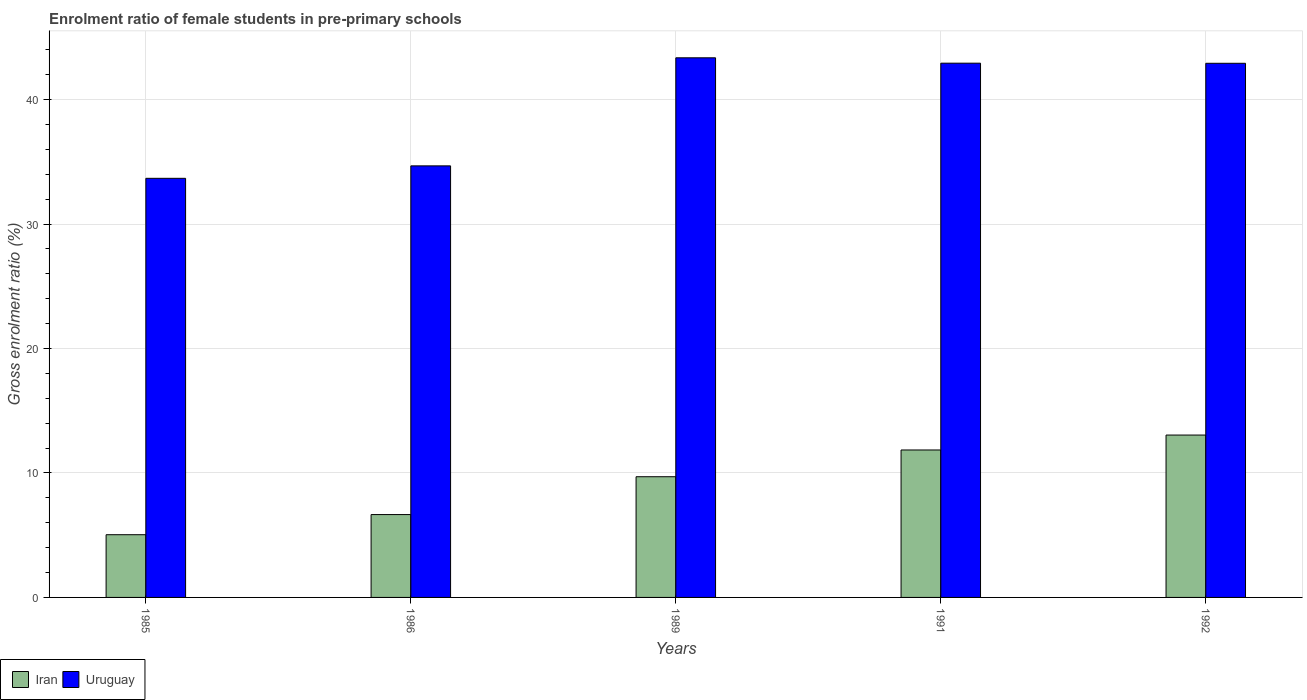Are the number of bars on each tick of the X-axis equal?
Ensure brevity in your answer.  Yes. What is the enrolment ratio of female students in pre-primary schools in Iran in 1992?
Offer a very short reply. 13.05. Across all years, what is the maximum enrolment ratio of female students in pre-primary schools in Uruguay?
Ensure brevity in your answer.  43.36. Across all years, what is the minimum enrolment ratio of female students in pre-primary schools in Uruguay?
Provide a short and direct response. 33.67. In which year was the enrolment ratio of female students in pre-primary schools in Uruguay maximum?
Your answer should be compact. 1989. In which year was the enrolment ratio of female students in pre-primary schools in Uruguay minimum?
Provide a succinct answer. 1985. What is the total enrolment ratio of female students in pre-primary schools in Uruguay in the graph?
Your answer should be compact. 197.55. What is the difference between the enrolment ratio of female students in pre-primary schools in Uruguay in 1985 and that in 1991?
Your answer should be compact. -9.25. What is the difference between the enrolment ratio of female students in pre-primary schools in Iran in 1992 and the enrolment ratio of female students in pre-primary schools in Uruguay in 1986?
Provide a succinct answer. -21.63. What is the average enrolment ratio of female students in pre-primary schools in Iran per year?
Your response must be concise. 9.26. In the year 1985, what is the difference between the enrolment ratio of female students in pre-primary schools in Uruguay and enrolment ratio of female students in pre-primary schools in Iran?
Keep it short and to the point. 28.64. What is the ratio of the enrolment ratio of female students in pre-primary schools in Iran in 1985 to that in 1989?
Keep it short and to the point. 0.52. Is the enrolment ratio of female students in pre-primary schools in Iran in 1985 less than that in 1989?
Your answer should be compact. Yes. What is the difference between the highest and the second highest enrolment ratio of female students in pre-primary schools in Uruguay?
Your answer should be very brief. 0.43. What is the difference between the highest and the lowest enrolment ratio of female students in pre-primary schools in Iran?
Make the answer very short. 8.01. In how many years, is the enrolment ratio of female students in pre-primary schools in Iran greater than the average enrolment ratio of female students in pre-primary schools in Iran taken over all years?
Provide a short and direct response. 3. Is the sum of the enrolment ratio of female students in pre-primary schools in Iran in 1985 and 1989 greater than the maximum enrolment ratio of female students in pre-primary schools in Uruguay across all years?
Give a very brief answer. No. What does the 1st bar from the left in 1989 represents?
Give a very brief answer. Iran. What does the 1st bar from the right in 1992 represents?
Offer a very short reply. Uruguay. How many bars are there?
Provide a succinct answer. 10. How many years are there in the graph?
Your answer should be very brief. 5. What is the difference between two consecutive major ticks on the Y-axis?
Provide a short and direct response. 10. Does the graph contain any zero values?
Offer a very short reply. No. Does the graph contain grids?
Your answer should be compact. Yes. Where does the legend appear in the graph?
Provide a succinct answer. Bottom left. How many legend labels are there?
Offer a very short reply. 2. How are the legend labels stacked?
Give a very brief answer. Horizontal. What is the title of the graph?
Your response must be concise. Enrolment ratio of female students in pre-primary schools. Does "Least developed countries" appear as one of the legend labels in the graph?
Provide a short and direct response. No. What is the label or title of the Y-axis?
Your answer should be compact. Gross enrolment ratio (%). What is the Gross enrolment ratio (%) in Iran in 1985?
Offer a terse response. 5.04. What is the Gross enrolment ratio (%) of Uruguay in 1985?
Give a very brief answer. 33.67. What is the Gross enrolment ratio (%) of Iran in 1986?
Offer a terse response. 6.66. What is the Gross enrolment ratio (%) of Uruguay in 1986?
Provide a succinct answer. 34.67. What is the Gross enrolment ratio (%) of Iran in 1989?
Your answer should be very brief. 9.7. What is the Gross enrolment ratio (%) of Uruguay in 1989?
Keep it short and to the point. 43.36. What is the Gross enrolment ratio (%) of Iran in 1991?
Offer a terse response. 11.85. What is the Gross enrolment ratio (%) of Uruguay in 1991?
Provide a succinct answer. 42.93. What is the Gross enrolment ratio (%) in Iran in 1992?
Ensure brevity in your answer.  13.05. What is the Gross enrolment ratio (%) in Uruguay in 1992?
Ensure brevity in your answer.  42.92. Across all years, what is the maximum Gross enrolment ratio (%) in Iran?
Keep it short and to the point. 13.05. Across all years, what is the maximum Gross enrolment ratio (%) in Uruguay?
Your response must be concise. 43.36. Across all years, what is the minimum Gross enrolment ratio (%) in Iran?
Keep it short and to the point. 5.04. Across all years, what is the minimum Gross enrolment ratio (%) of Uruguay?
Ensure brevity in your answer.  33.67. What is the total Gross enrolment ratio (%) in Iran in the graph?
Your answer should be compact. 46.29. What is the total Gross enrolment ratio (%) in Uruguay in the graph?
Offer a terse response. 197.55. What is the difference between the Gross enrolment ratio (%) of Iran in 1985 and that in 1986?
Make the answer very short. -1.62. What is the difference between the Gross enrolment ratio (%) of Uruguay in 1985 and that in 1986?
Ensure brevity in your answer.  -1. What is the difference between the Gross enrolment ratio (%) in Iran in 1985 and that in 1989?
Keep it short and to the point. -4.66. What is the difference between the Gross enrolment ratio (%) of Uruguay in 1985 and that in 1989?
Offer a very short reply. -9.68. What is the difference between the Gross enrolment ratio (%) in Iran in 1985 and that in 1991?
Your response must be concise. -6.81. What is the difference between the Gross enrolment ratio (%) in Uruguay in 1985 and that in 1991?
Provide a succinct answer. -9.25. What is the difference between the Gross enrolment ratio (%) of Iran in 1985 and that in 1992?
Give a very brief answer. -8.01. What is the difference between the Gross enrolment ratio (%) in Uruguay in 1985 and that in 1992?
Your answer should be compact. -9.24. What is the difference between the Gross enrolment ratio (%) of Iran in 1986 and that in 1989?
Provide a short and direct response. -3.04. What is the difference between the Gross enrolment ratio (%) of Uruguay in 1986 and that in 1989?
Keep it short and to the point. -8.68. What is the difference between the Gross enrolment ratio (%) of Iran in 1986 and that in 1991?
Offer a very short reply. -5.19. What is the difference between the Gross enrolment ratio (%) of Uruguay in 1986 and that in 1991?
Offer a very short reply. -8.25. What is the difference between the Gross enrolment ratio (%) in Iran in 1986 and that in 1992?
Provide a succinct answer. -6.39. What is the difference between the Gross enrolment ratio (%) in Uruguay in 1986 and that in 1992?
Offer a very short reply. -8.24. What is the difference between the Gross enrolment ratio (%) of Iran in 1989 and that in 1991?
Your response must be concise. -2.15. What is the difference between the Gross enrolment ratio (%) of Uruguay in 1989 and that in 1991?
Give a very brief answer. 0.43. What is the difference between the Gross enrolment ratio (%) in Iran in 1989 and that in 1992?
Your response must be concise. -3.35. What is the difference between the Gross enrolment ratio (%) in Uruguay in 1989 and that in 1992?
Offer a very short reply. 0.44. What is the difference between the Gross enrolment ratio (%) in Iran in 1991 and that in 1992?
Your response must be concise. -1.2. What is the difference between the Gross enrolment ratio (%) of Uruguay in 1991 and that in 1992?
Offer a very short reply. 0.01. What is the difference between the Gross enrolment ratio (%) in Iran in 1985 and the Gross enrolment ratio (%) in Uruguay in 1986?
Keep it short and to the point. -29.64. What is the difference between the Gross enrolment ratio (%) of Iran in 1985 and the Gross enrolment ratio (%) of Uruguay in 1989?
Offer a terse response. -38.32. What is the difference between the Gross enrolment ratio (%) in Iran in 1985 and the Gross enrolment ratio (%) in Uruguay in 1991?
Provide a short and direct response. -37.89. What is the difference between the Gross enrolment ratio (%) in Iran in 1985 and the Gross enrolment ratio (%) in Uruguay in 1992?
Provide a succinct answer. -37.88. What is the difference between the Gross enrolment ratio (%) of Iran in 1986 and the Gross enrolment ratio (%) of Uruguay in 1989?
Make the answer very short. -36.7. What is the difference between the Gross enrolment ratio (%) in Iran in 1986 and the Gross enrolment ratio (%) in Uruguay in 1991?
Keep it short and to the point. -36.27. What is the difference between the Gross enrolment ratio (%) in Iran in 1986 and the Gross enrolment ratio (%) in Uruguay in 1992?
Your answer should be very brief. -36.26. What is the difference between the Gross enrolment ratio (%) of Iran in 1989 and the Gross enrolment ratio (%) of Uruguay in 1991?
Give a very brief answer. -33.23. What is the difference between the Gross enrolment ratio (%) in Iran in 1989 and the Gross enrolment ratio (%) in Uruguay in 1992?
Offer a very short reply. -33.22. What is the difference between the Gross enrolment ratio (%) in Iran in 1991 and the Gross enrolment ratio (%) in Uruguay in 1992?
Offer a terse response. -31.07. What is the average Gross enrolment ratio (%) in Iran per year?
Your response must be concise. 9.26. What is the average Gross enrolment ratio (%) of Uruguay per year?
Your response must be concise. 39.51. In the year 1985, what is the difference between the Gross enrolment ratio (%) of Iran and Gross enrolment ratio (%) of Uruguay?
Your answer should be very brief. -28.64. In the year 1986, what is the difference between the Gross enrolment ratio (%) of Iran and Gross enrolment ratio (%) of Uruguay?
Provide a succinct answer. -28.02. In the year 1989, what is the difference between the Gross enrolment ratio (%) in Iran and Gross enrolment ratio (%) in Uruguay?
Provide a succinct answer. -33.66. In the year 1991, what is the difference between the Gross enrolment ratio (%) in Iran and Gross enrolment ratio (%) in Uruguay?
Provide a short and direct response. -31.08. In the year 1992, what is the difference between the Gross enrolment ratio (%) of Iran and Gross enrolment ratio (%) of Uruguay?
Ensure brevity in your answer.  -29.87. What is the ratio of the Gross enrolment ratio (%) in Iran in 1985 to that in 1986?
Offer a terse response. 0.76. What is the ratio of the Gross enrolment ratio (%) of Uruguay in 1985 to that in 1986?
Offer a very short reply. 0.97. What is the ratio of the Gross enrolment ratio (%) in Iran in 1985 to that in 1989?
Make the answer very short. 0.52. What is the ratio of the Gross enrolment ratio (%) in Uruguay in 1985 to that in 1989?
Your response must be concise. 0.78. What is the ratio of the Gross enrolment ratio (%) in Iran in 1985 to that in 1991?
Provide a succinct answer. 0.43. What is the ratio of the Gross enrolment ratio (%) of Uruguay in 1985 to that in 1991?
Offer a very short reply. 0.78. What is the ratio of the Gross enrolment ratio (%) in Iran in 1985 to that in 1992?
Offer a terse response. 0.39. What is the ratio of the Gross enrolment ratio (%) of Uruguay in 1985 to that in 1992?
Your answer should be compact. 0.78. What is the ratio of the Gross enrolment ratio (%) in Iran in 1986 to that in 1989?
Your answer should be very brief. 0.69. What is the ratio of the Gross enrolment ratio (%) in Uruguay in 1986 to that in 1989?
Provide a succinct answer. 0.8. What is the ratio of the Gross enrolment ratio (%) of Iran in 1986 to that in 1991?
Offer a very short reply. 0.56. What is the ratio of the Gross enrolment ratio (%) of Uruguay in 1986 to that in 1991?
Your answer should be compact. 0.81. What is the ratio of the Gross enrolment ratio (%) in Iran in 1986 to that in 1992?
Offer a terse response. 0.51. What is the ratio of the Gross enrolment ratio (%) of Uruguay in 1986 to that in 1992?
Provide a succinct answer. 0.81. What is the ratio of the Gross enrolment ratio (%) of Iran in 1989 to that in 1991?
Offer a terse response. 0.82. What is the ratio of the Gross enrolment ratio (%) of Iran in 1989 to that in 1992?
Provide a short and direct response. 0.74. What is the ratio of the Gross enrolment ratio (%) in Uruguay in 1989 to that in 1992?
Make the answer very short. 1.01. What is the ratio of the Gross enrolment ratio (%) of Iran in 1991 to that in 1992?
Offer a terse response. 0.91. What is the ratio of the Gross enrolment ratio (%) in Uruguay in 1991 to that in 1992?
Give a very brief answer. 1. What is the difference between the highest and the second highest Gross enrolment ratio (%) of Iran?
Offer a very short reply. 1.2. What is the difference between the highest and the second highest Gross enrolment ratio (%) of Uruguay?
Offer a very short reply. 0.43. What is the difference between the highest and the lowest Gross enrolment ratio (%) of Iran?
Your answer should be compact. 8.01. What is the difference between the highest and the lowest Gross enrolment ratio (%) in Uruguay?
Give a very brief answer. 9.68. 